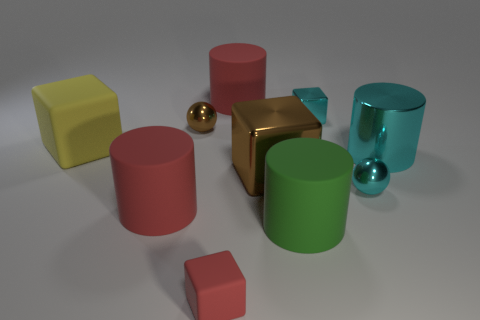Does the metallic cylinder have the same color as the tiny metallic block?
Offer a very short reply. Yes. Do the brown thing that is right of the small red block and the tiny cyan metallic object that is behind the big brown object have the same shape?
Offer a very short reply. Yes. What number of things are shiny things behind the large brown object or brown things behind the yellow object?
Your answer should be compact. 3. How many other objects are there of the same material as the yellow thing?
Ensure brevity in your answer.  4. Does the large red thing that is behind the yellow object have the same material as the red block?
Your answer should be very brief. Yes. Is the number of cylinders that are on the right side of the large green object greater than the number of small brown metal objects on the right side of the small metal block?
Keep it short and to the point. Yes. How many objects are either red cylinders in front of the small cyan cube or large green things?
Provide a succinct answer. 2. What is the shape of the large yellow object that is the same material as the green object?
Offer a very short reply. Cube. Are there any other things that have the same shape as the yellow object?
Your response must be concise. Yes. The tiny object that is behind the yellow object and right of the big metal cube is what color?
Your answer should be compact. Cyan. 